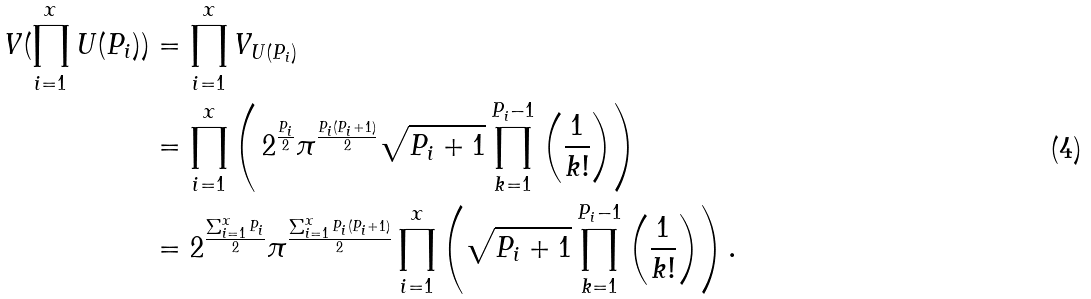<formula> <loc_0><loc_0><loc_500><loc_500>V ( \prod _ { i = 1 } ^ { x } { U } ( P _ { i } ) ) & = \prod _ { i = 1 } ^ { x } V _ { { U } ( P _ { i } ) } \\ & = \prod _ { i = 1 } ^ { x } \left ( \, 2 ^ { \frac { P _ { i } } { 2 } } \pi ^ { \frac { P _ { i } ( P _ { i } + 1 ) } { 2 } } \sqrt { P _ { i } + 1 } \prod ^ { P _ { i } - 1 } _ { k = 1 } \left ( \frac { 1 } { k ! } \right ) \right ) \\ & = 2 ^ { \frac { \sum _ { i = 1 } ^ { x } P _ { i } } { 2 } } \pi ^ { \frac { \sum _ { i = 1 } ^ { x } P _ { i } ( P _ { i } + 1 ) } { 2 } } \prod _ { i = 1 } ^ { x } \left ( \sqrt { P _ { i } + 1 } \prod ^ { P _ { i } - 1 } _ { k = 1 } \left ( \frac { 1 } { k ! } \right ) \right ) .</formula> 